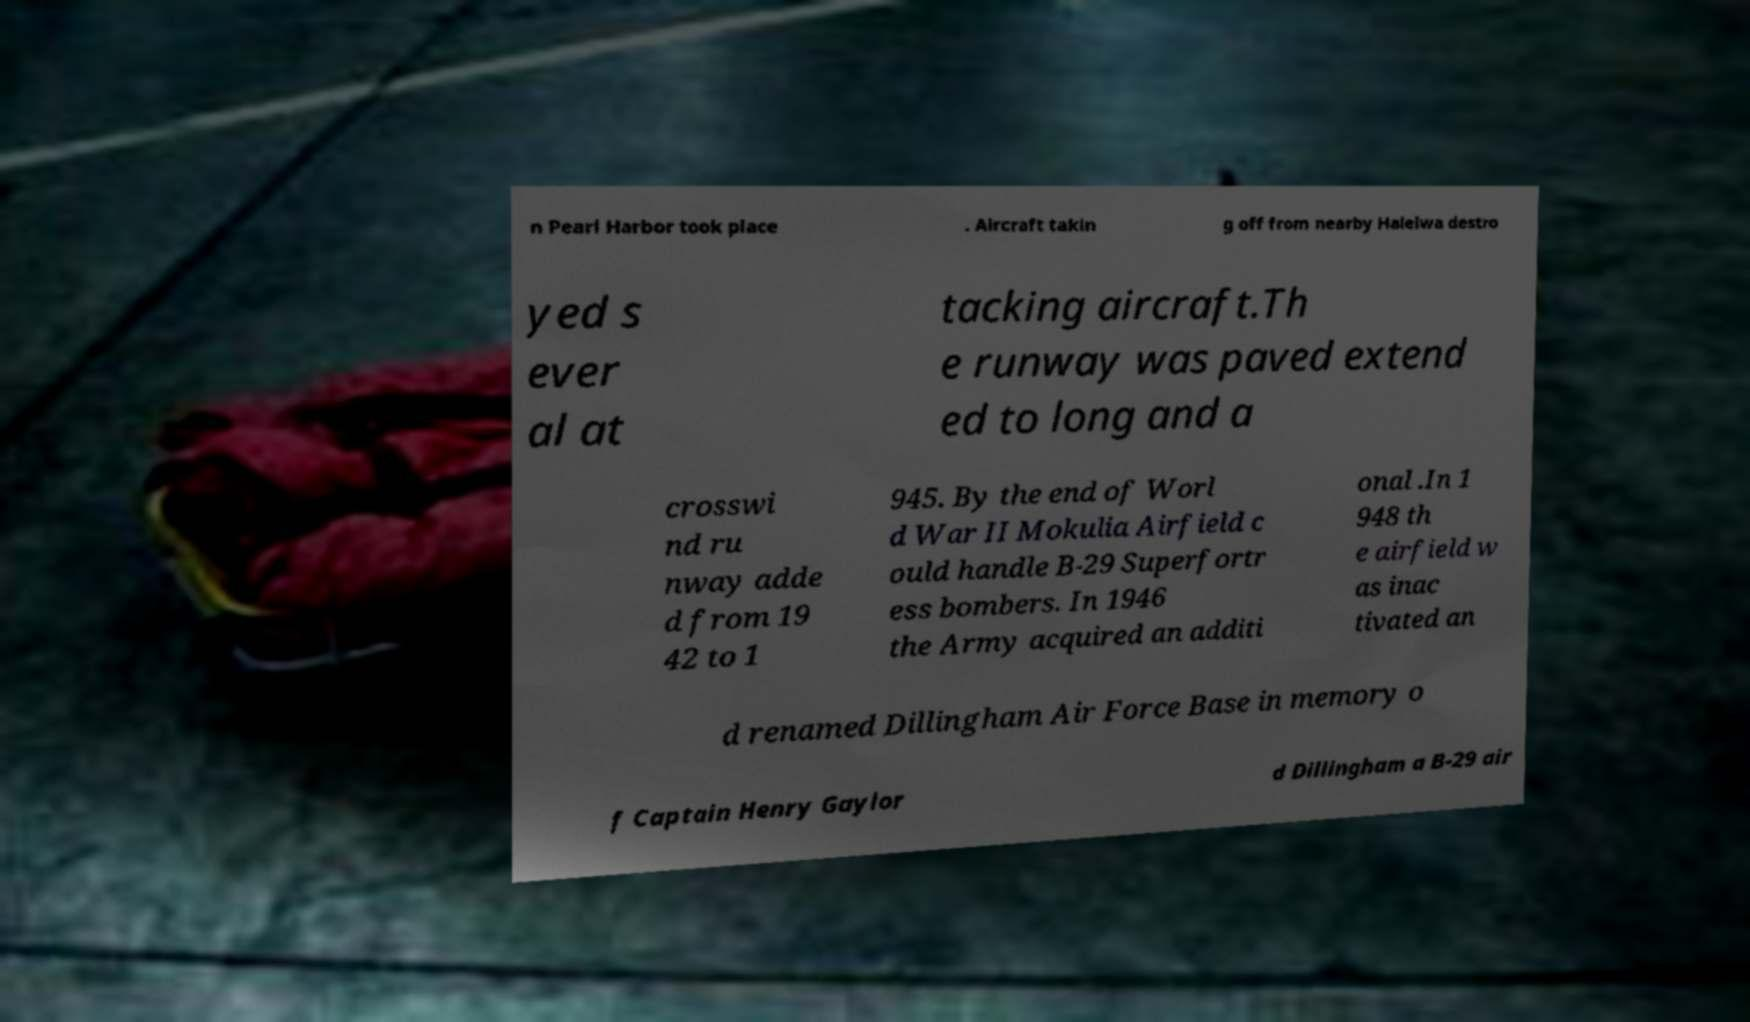Can you read and provide the text displayed in the image?This photo seems to have some interesting text. Can you extract and type it out for me? n Pearl Harbor took place . Aircraft takin g off from nearby Haleiwa destro yed s ever al at tacking aircraft.Th e runway was paved extend ed to long and a crosswi nd ru nway adde d from 19 42 to 1 945. By the end of Worl d War II Mokulia Airfield c ould handle B-29 Superfortr ess bombers. In 1946 the Army acquired an additi onal .In 1 948 th e airfield w as inac tivated an d renamed Dillingham Air Force Base in memory o f Captain Henry Gaylor d Dillingham a B-29 air 